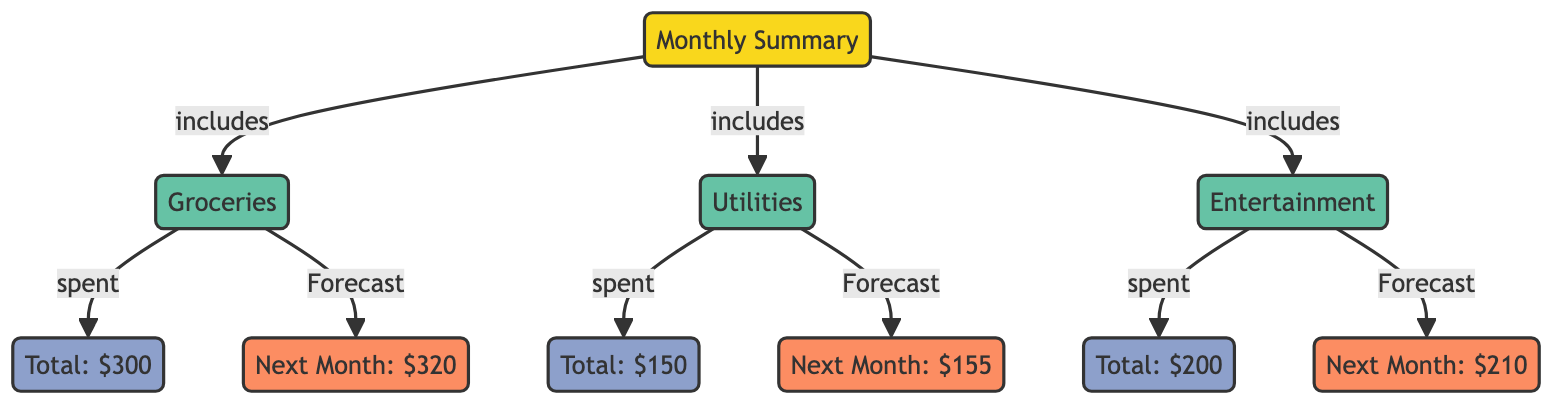What are the total expenses for groceries? The total expense for groceries is directly labeled in the diagram as "$300".
Answer: $300 What is the total expense for utilities? The total expense for utilities is shown in the diagram as "$150".
Answer: $150 What is the predicted spending for entertainment next month? The prediction for entertainment spending next month is indicated as "$210" in the diagram.
Answer: $210 How many categories are included in the monthly summary? The diagram shows three distinct categories under the monthly summary: groceries, utilities, and entertainment.
Answer: 3 What is the next month's predicted expense for groceries? The next month's predicted expense for groceries is labeled as "$320" within the diagram.
Answer: $320 What is the relationship between entertainment and its total expense? The diagram shows that entertainment is connected to its total expense via the "spent" label, indicating that total expenses specifically refer to entertainment.
Answer: spent Which category has the highest total expense? The highest total expense is found under the groceries category, which is "$300".
Answer: Groceries What is the total expense for all categories combined? To find the total of all expenses, add together $300 (groceries), $150 (utilities), and $200 (entertainment), yielding $650.
Answer: $650 Which category is projected to have the least increase in spending next month? The predicted increase for utilities is from $150 to $155, which is the lowest increase compared to groceries and entertainment.
Answer: Utilities 